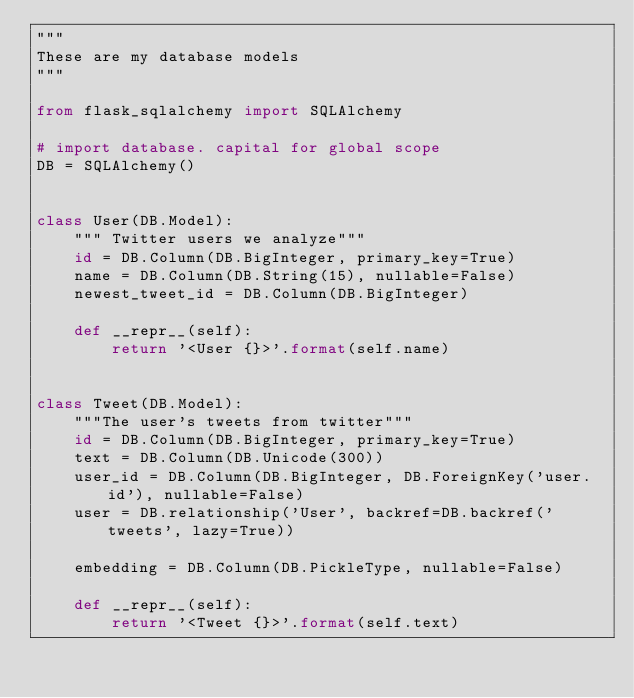Convert code to text. <code><loc_0><loc_0><loc_500><loc_500><_Python_>"""
These are my database models
"""

from flask_sqlalchemy import SQLAlchemy

# import database. capital for global scope
DB = SQLAlchemy()


class User(DB.Model):
    """ Twitter users we analyze"""
    id = DB.Column(DB.BigInteger, primary_key=True)
    name = DB.Column(DB.String(15), nullable=False)
    newest_tweet_id = DB.Column(DB.BigInteger)

    def __repr__(self):
        return '<User {}>'.format(self.name)


class Tweet(DB.Model):
    """The user's tweets from twitter"""
    id = DB.Column(DB.BigInteger, primary_key=True)
    text = DB.Column(DB.Unicode(300))
    user_id = DB.Column(DB.BigInteger, DB.ForeignKey('user.id'), nullable=False)
    user = DB.relationship('User', backref=DB.backref('tweets', lazy=True))

    embedding = DB.Column(DB.PickleType, nullable=False)

    def __repr__(self):
        return '<Tweet {}>'.format(self.text)
</code> 